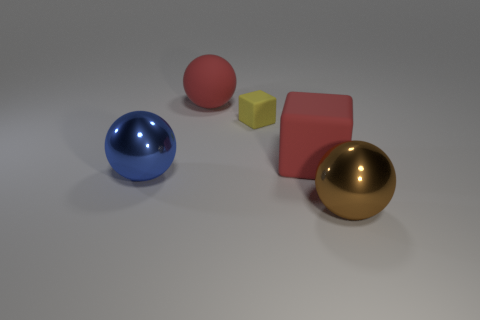Subtract all large metal balls. How many balls are left? 1 Add 2 tiny yellow metallic cylinders. How many objects exist? 7 Subtract 1 spheres. How many spheres are left? 2 Subtract all red blocks. How many blocks are left? 1 Subtract 0 yellow cylinders. How many objects are left? 5 Subtract all cubes. How many objects are left? 3 Subtract all blue cubes. Subtract all brown balls. How many cubes are left? 2 Subtract all blue cylinders. Subtract all large rubber blocks. How many objects are left? 4 Add 5 tiny yellow cubes. How many tiny yellow cubes are left? 6 Add 1 green metallic cylinders. How many green metallic cylinders exist? 1 